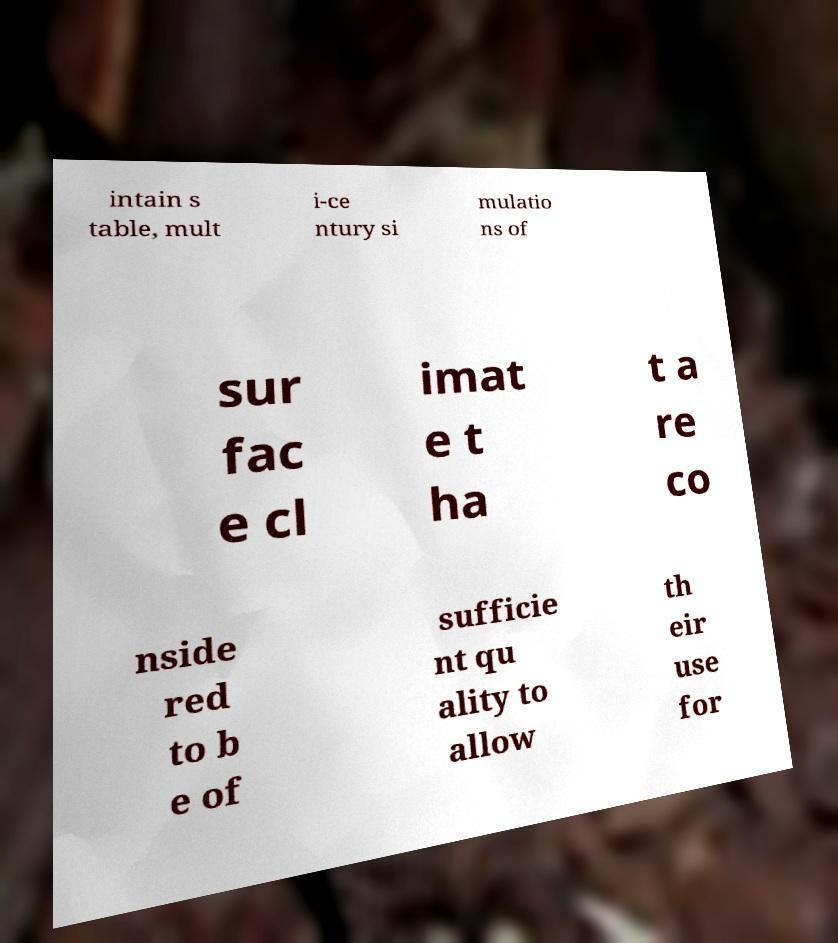Could you extract and type out the text from this image? intain s table, mult i-ce ntury si mulatio ns of sur fac e cl imat e t ha t a re co nside red to b e of sufficie nt qu ality to allow th eir use for 